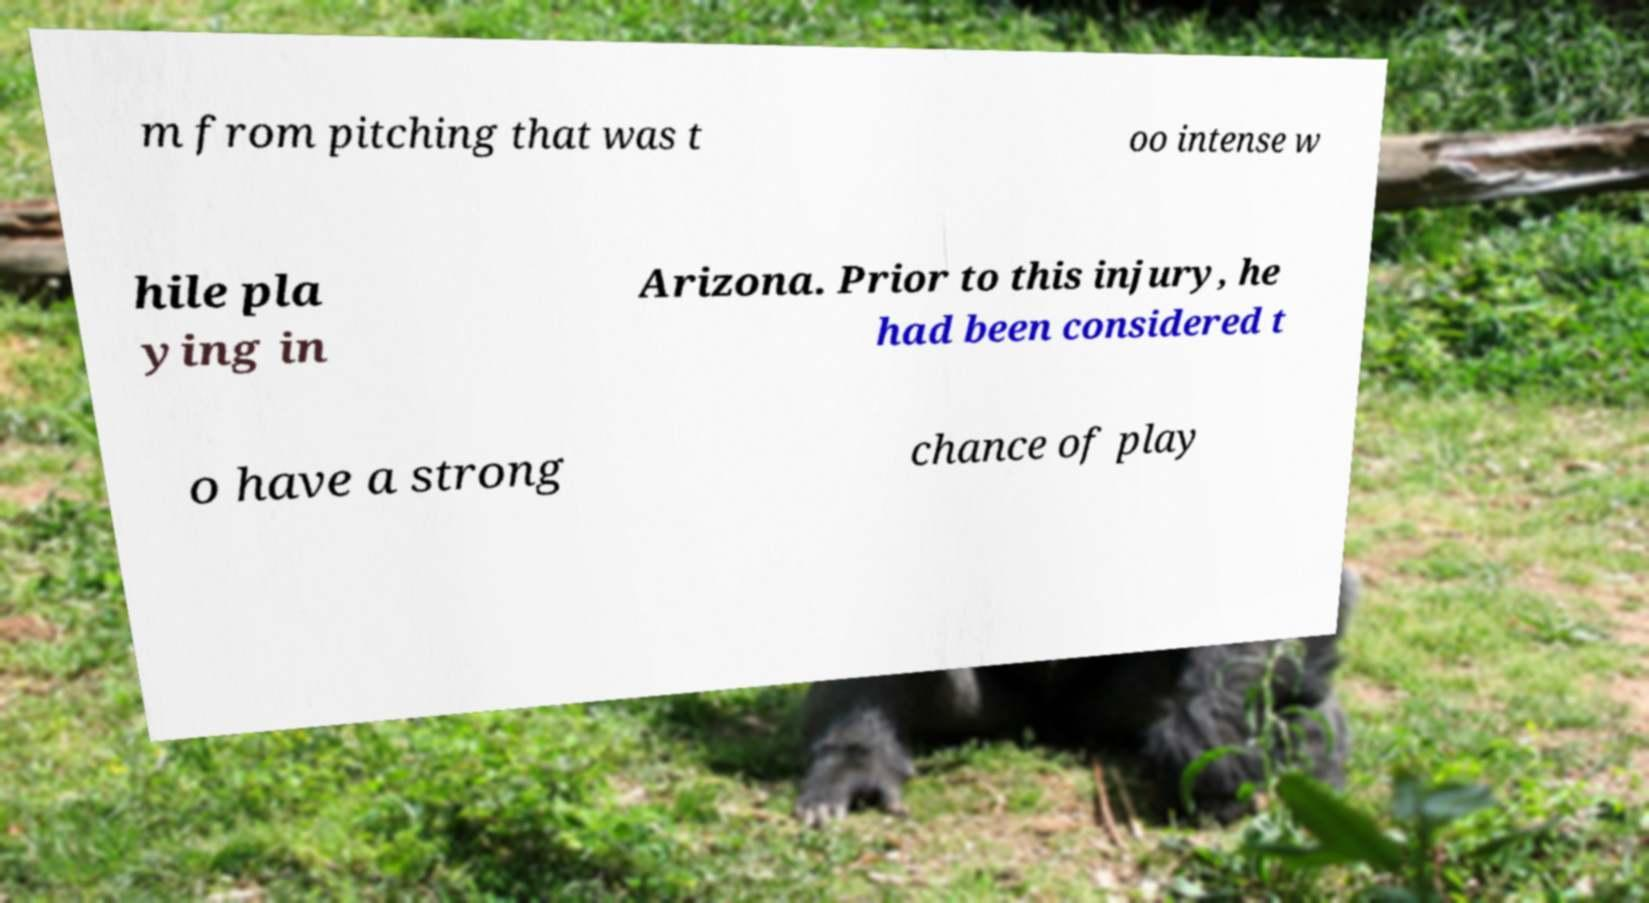Please identify and transcribe the text found in this image. m from pitching that was t oo intense w hile pla ying in Arizona. Prior to this injury, he had been considered t o have a strong chance of play 